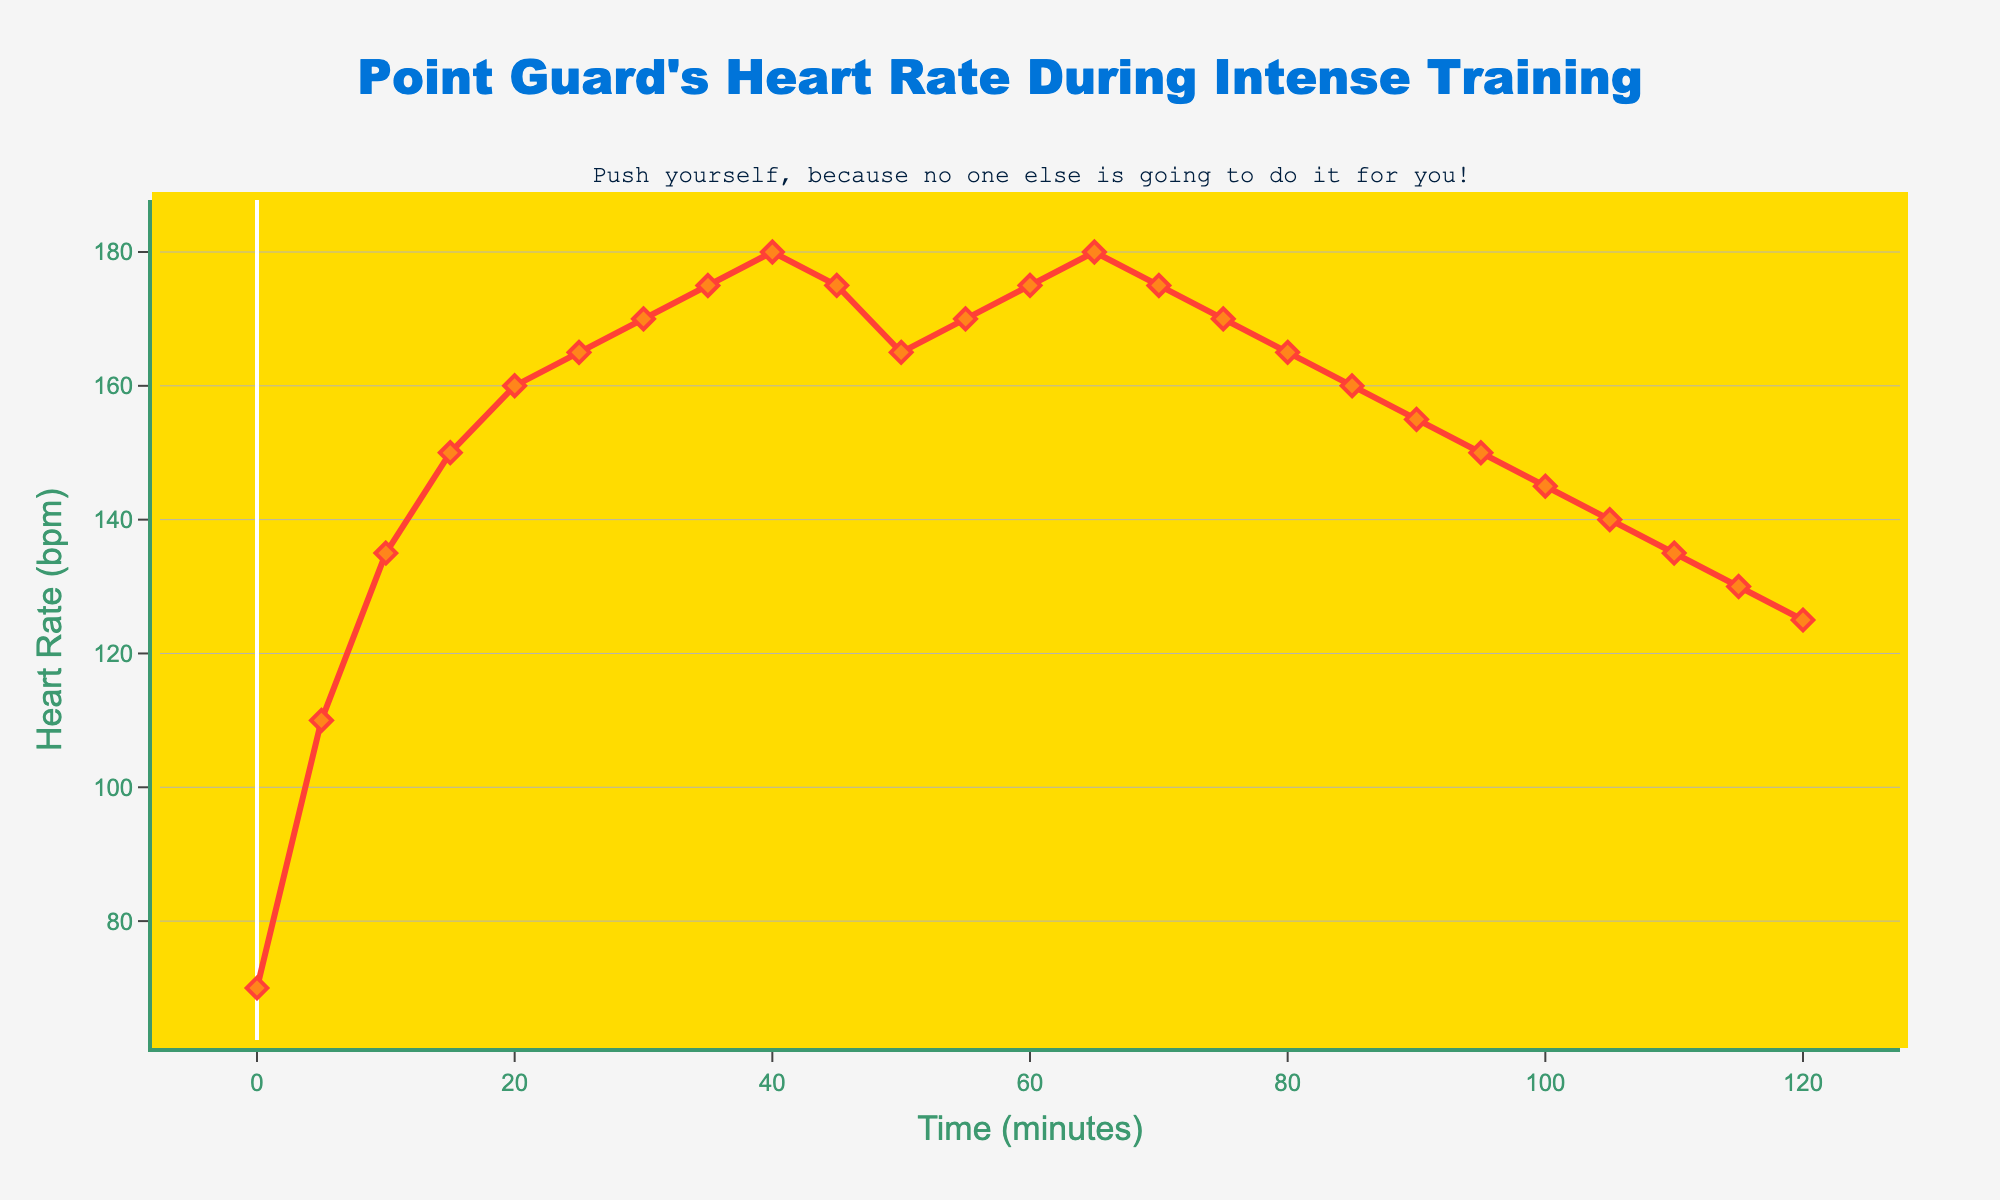What is the highest heart rate reached during the training session? The highest point on the plot corresponds to the peak heart rate during the training. Look at the highest y-coordinate and read its value.
Answer: 180 bpm At which time intervals does the heart rate drop from 175 bpm to 165 bpm? Look for the heart rate values of 175 and 165 bpm. Then, identify the time intervals where this drop occurs on the x-axis.
Answer: 45 to 50 minutes, 75 to 80 minutes What is the average heart rate from the 20th minute to the 50th minute? Identify heart rate values at 20, 25, 30, 35, 40, 45, and 50 minutes. Add these values and divide by the number of intervals.
Answer: (160+165+170+175+180+175+165) / 7 = 170 bpm How does the heart rate compare from the start to the end of the training session? Note heart rate at the start (0 minutes) and at the end (120 minutes). Compare these y-values.
Answer: Start: 70 bpm, End: 125 bpm During what period does the heart rate remain consistently above 170 bpm? Identify where the heart rate stays above 170 bpm. Check the time intervals corresponding to these values.
Answer: 30 to 45 minutes, 60 to 70 minutes What is the visual appearance of the markers representing heart rate values on the plot? Identify and describe the markers' shape, size, and color in the plot.
Answer: Diamond-shaped, medium size, orange color with red outline How many times does the heart rate hit exactly 175 bpm during the training session? Scan through the heart rate values and count occurrences of 175 bpm on the y-axis.
Answer: 4 times What trend is observed in the heart rate from 90 minutes to 120 minutes? Trace the heart rate values from 90 to 120 minutes on the plot. Describe the direction of the line.
Answer: Downward trend from 155 bpm to 125 bpm What is the heart rate at the midpoint of the training session? Locate the time corresponding to half the total session time (60 minutes) and note the heart rate value at this point.
Answer: 175 bpm 